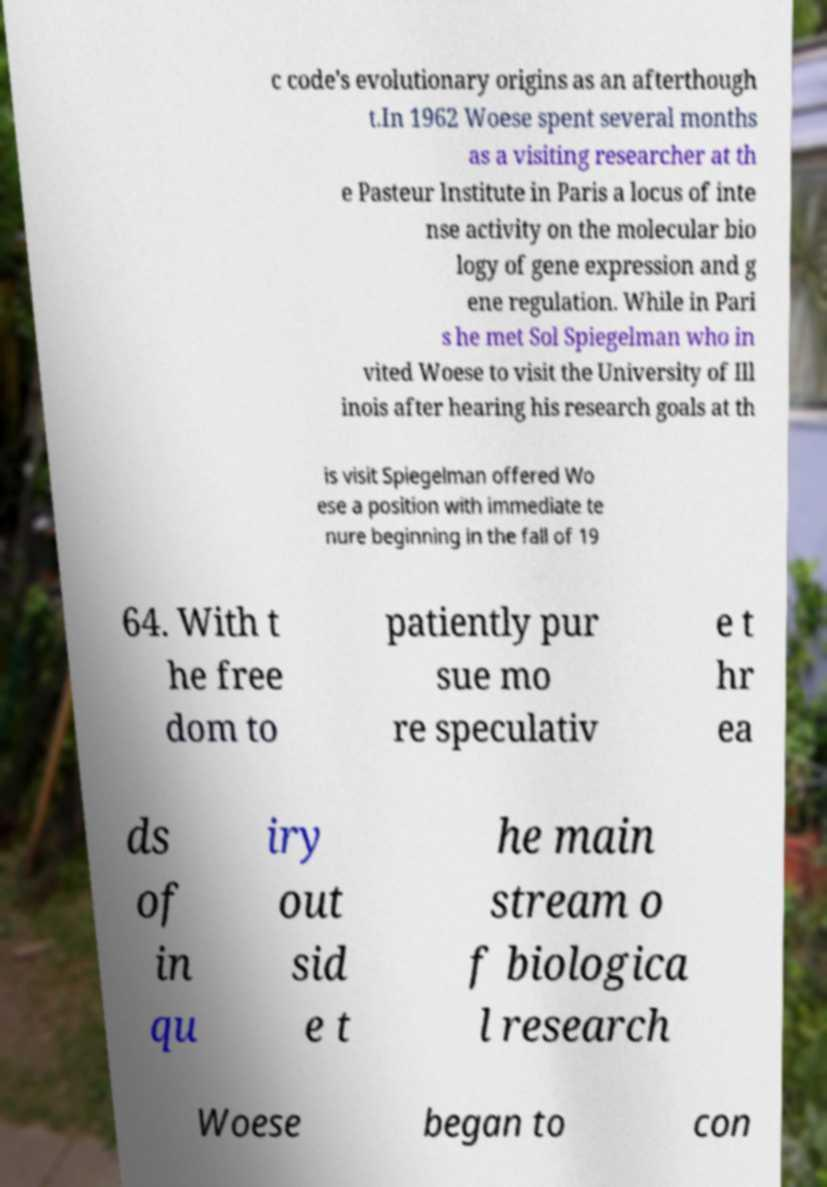I need the written content from this picture converted into text. Can you do that? c code's evolutionary origins as an afterthough t.In 1962 Woese spent several months as a visiting researcher at th e Pasteur Institute in Paris a locus of inte nse activity on the molecular bio logy of gene expression and g ene regulation. While in Pari s he met Sol Spiegelman who in vited Woese to visit the University of Ill inois after hearing his research goals at th is visit Spiegelman offered Wo ese a position with immediate te nure beginning in the fall of 19 64. With t he free dom to patiently pur sue mo re speculativ e t hr ea ds of in qu iry out sid e t he main stream o f biologica l research Woese began to con 